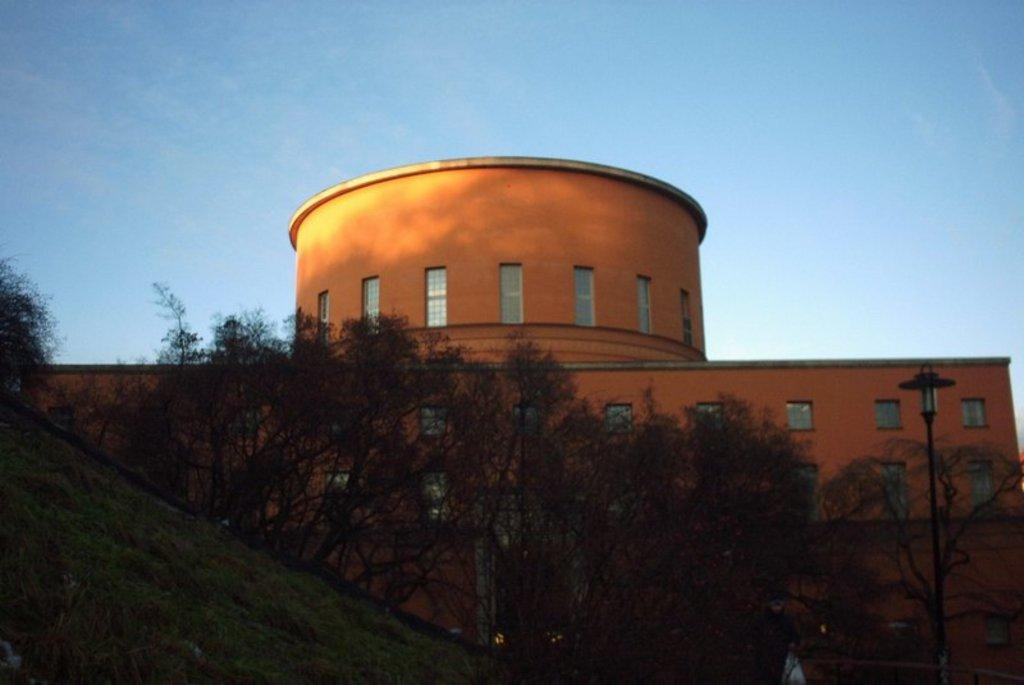What type of natural elements can be seen in the image? There are trees in the image. What type of man-made structures are present in the image? There are buildings in the image. What feature of the buildings can be seen in the image? There are windows in the image. What is visible in the background of the image? The sky is visible in the image. Where is the match stored in the image? There is no match present in the image. What color is the drawer in the image? There is no drawer present in the image. 